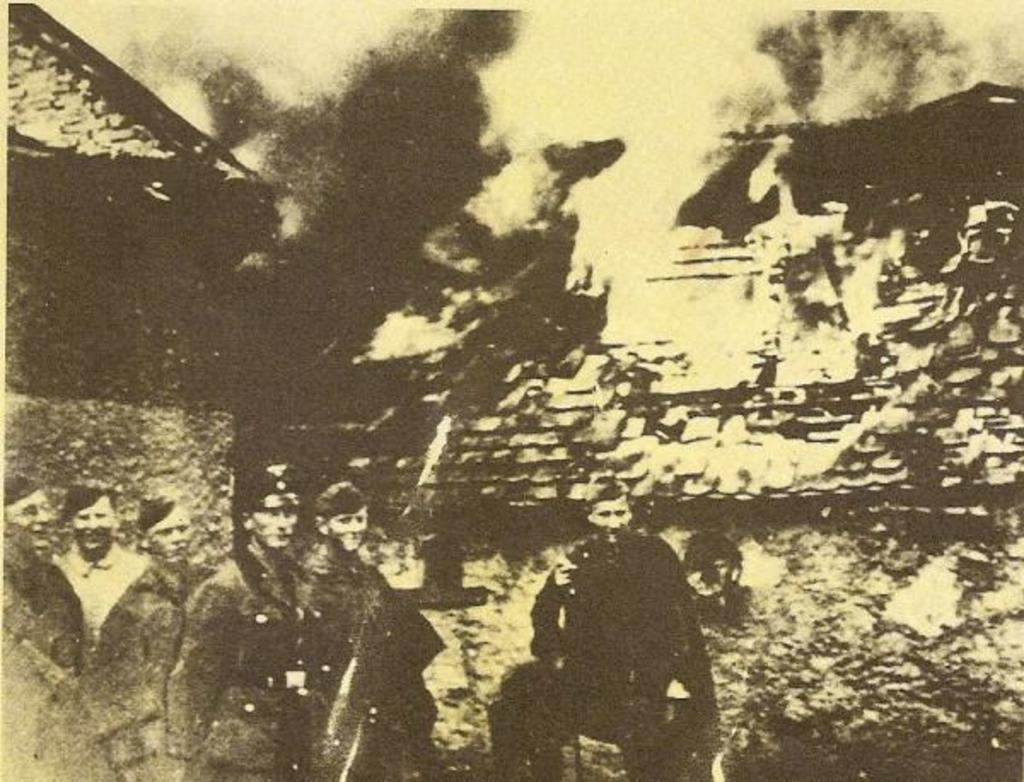What is the color scheme of the image? The image is black and white. Can you describe the subjects in the image? There are people in the image. What can be seen in the background of the image? There are buildings in the background of the image. How would you describe the clarity of the image? The image is blurry. What type of branch is being used as a design element in the image? There is no branch present in the image. Can you describe the veins in the people's arms in the image? The image is in black and white, so it is not possible to see the veins in the people's arms. 